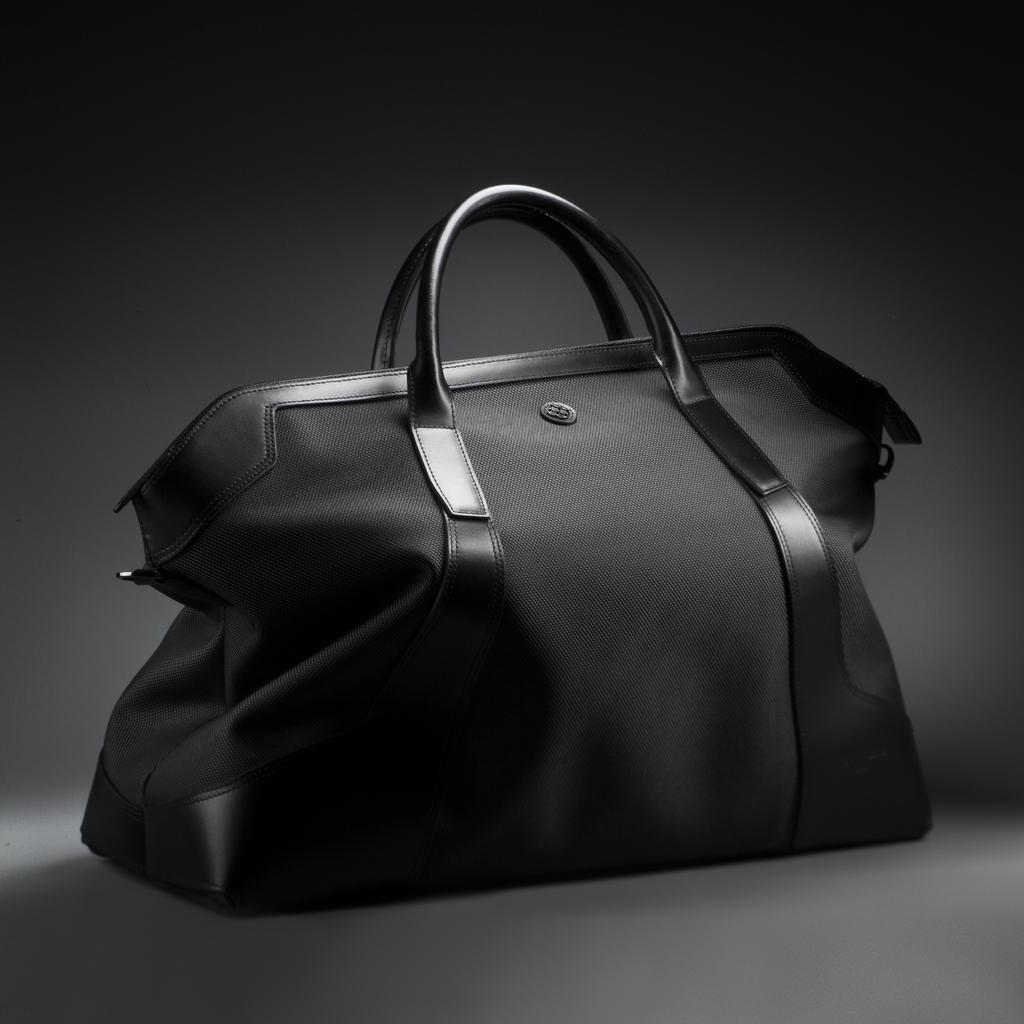What is the color of the handbag in the image? The handbag is black in color. How many grains of rice are in the handbag in the image? There is no indication of rice or grains in the image, as it only features a black handbag. 